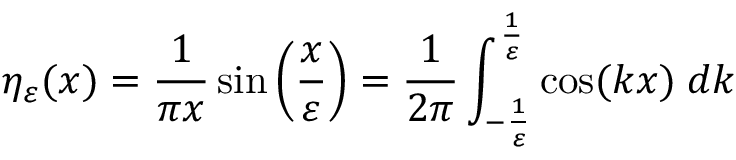<formula> <loc_0><loc_0><loc_500><loc_500>\eta _ { \varepsilon } ( x ) = { \frac { 1 } { \pi x } } \sin \left ( { \frac { x } { \varepsilon } } \right ) = { \frac { 1 } { 2 \pi } } \int _ { - { \frac { 1 } { \varepsilon } } } ^ { \frac { 1 } { \varepsilon } } \cos ( k x ) \, d k</formula> 